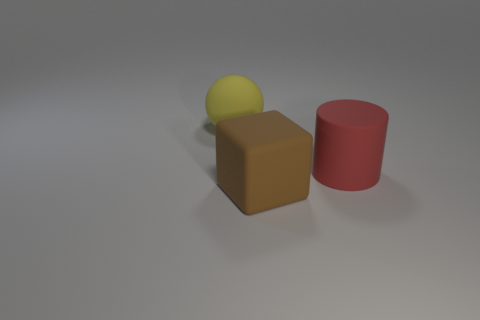Add 1 big brown objects. How many objects exist? 4 Subtract all balls. How many objects are left? 2 Subtract 1 brown cubes. How many objects are left? 2 Subtract all brown matte blocks. Subtract all red rubber cylinders. How many objects are left? 1 Add 2 large matte spheres. How many large matte spheres are left? 3 Add 3 large rubber things. How many large rubber things exist? 6 